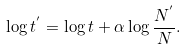Convert formula to latex. <formula><loc_0><loc_0><loc_500><loc_500>\log { t ^ { ^ { \prime } } } = \log { t } + \alpha \log { \frac { N ^ { ^ { \prime } } } { N } } .</formula> 